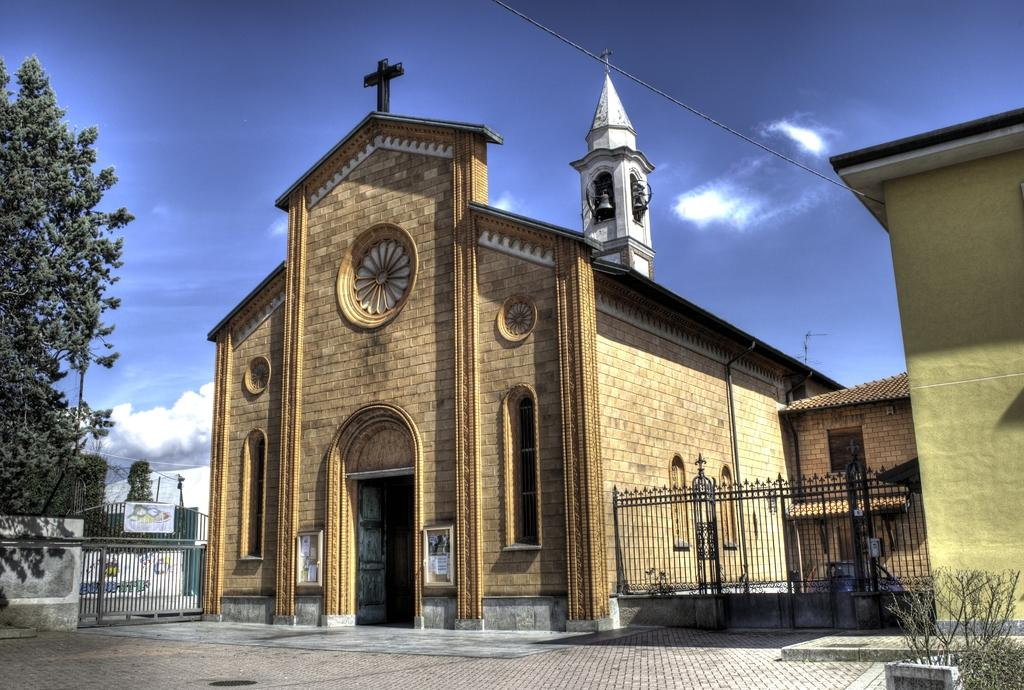What type of building is shown in the image? The image depicts a church. What is surrounding the church? There is fencing around the church. What can be seen on the left side of the image? There are trees on the left side of the image. What is present above the church in the image? There is a wire above the church. What is visible in the background of the image? The sky is visible in the background of the image. What type of wool is being used to create the stem of the popcorn in the image? There is no wool, stem, or popcorn present in the image; it features a church with fencing, trees, a wire, and a visible sky. 